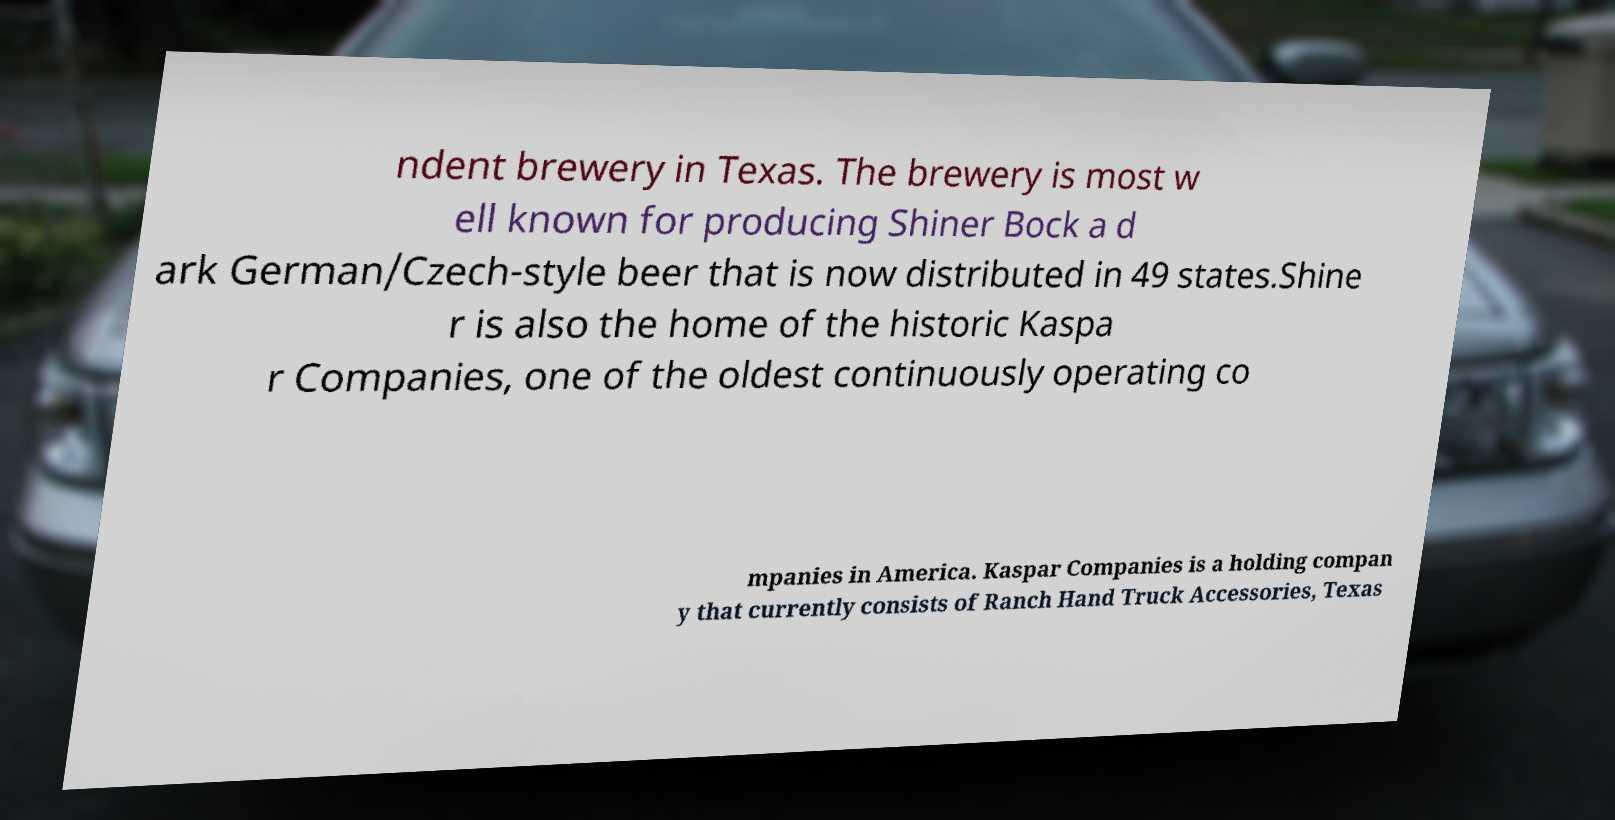Can you accurately transcribe the text from the provided image for me? ndent brewery in Texas. The brewery is most w ell known for producing Shiner Bock a d ark German/Czech-style beer that is now distributed in 49 states.Shine r is also the home of the historic Kaspa r Companies, one of the oldest continuously operating co mpanies in America. Kaspar Companies is a holding compan y that currently consists of Ranch Hand Truck Accessories, Texas 